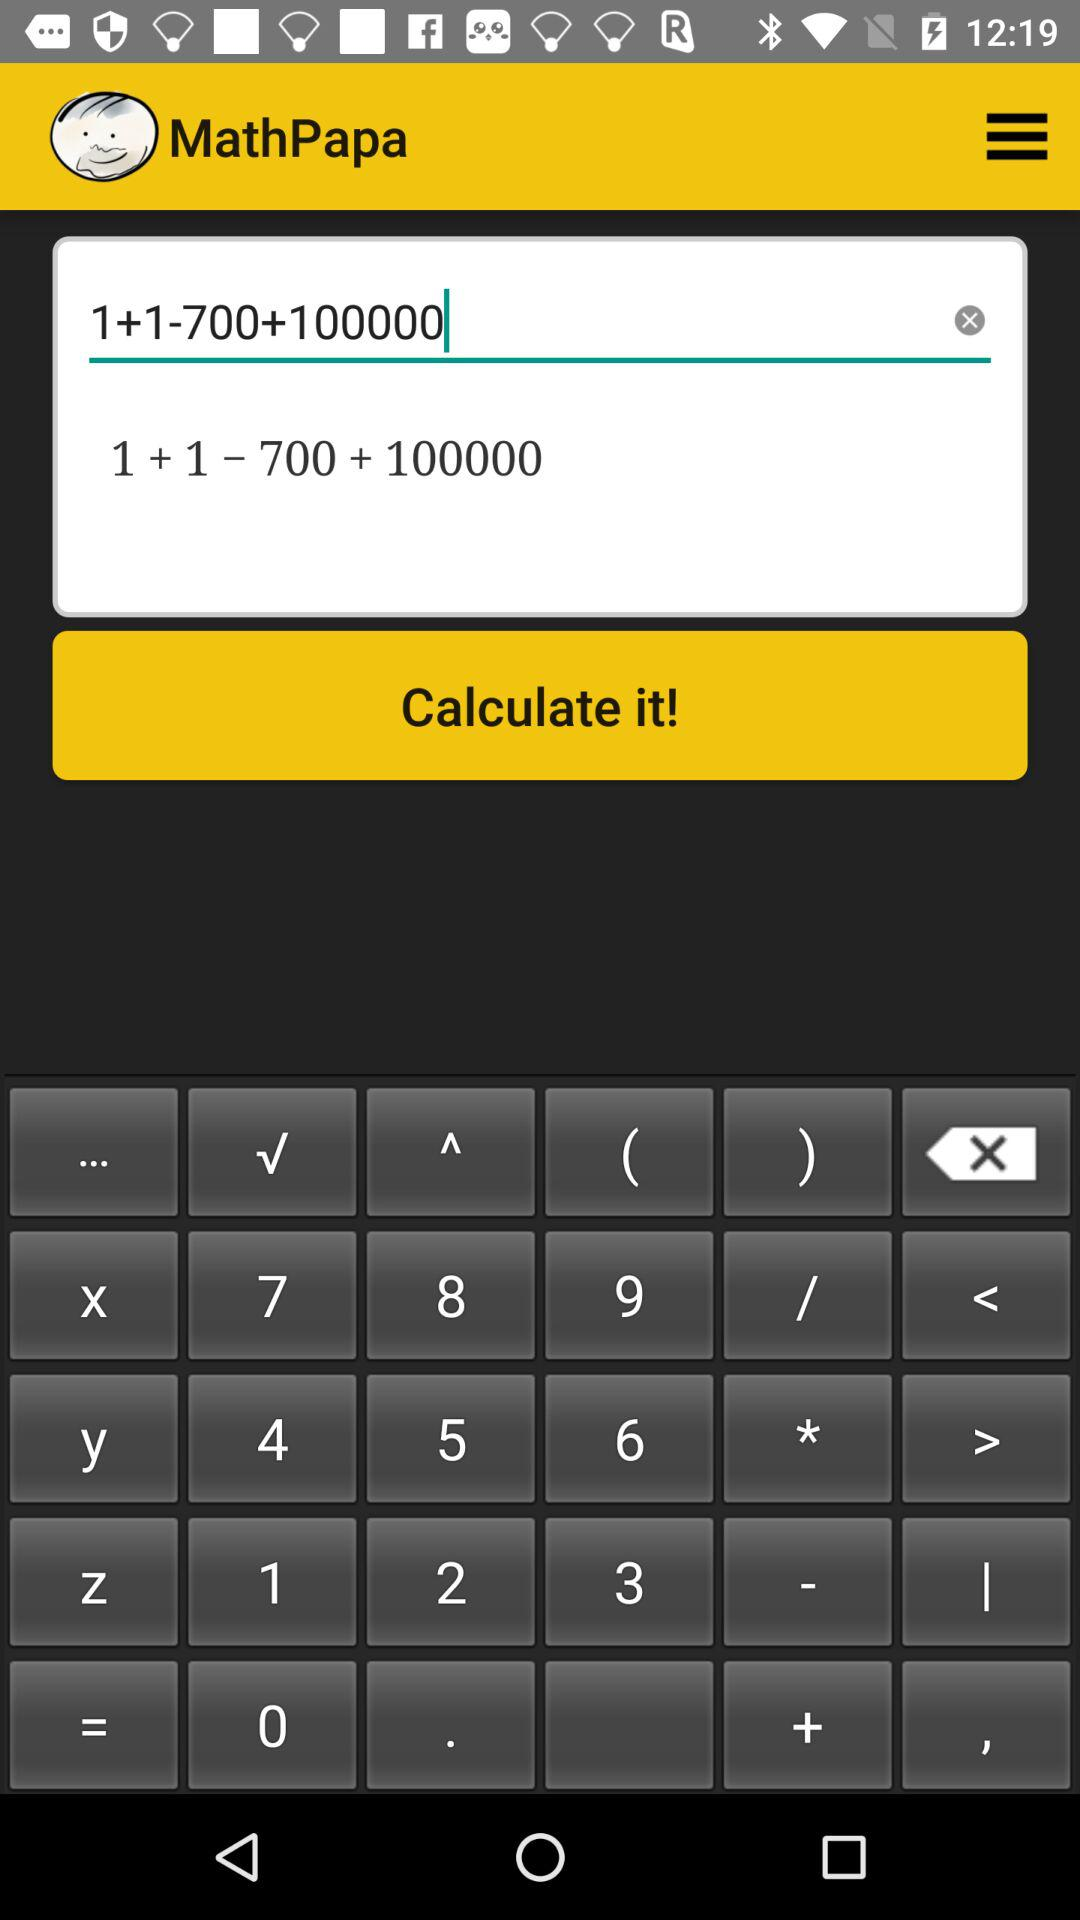What is the application name? The application name is "MathPapa". 